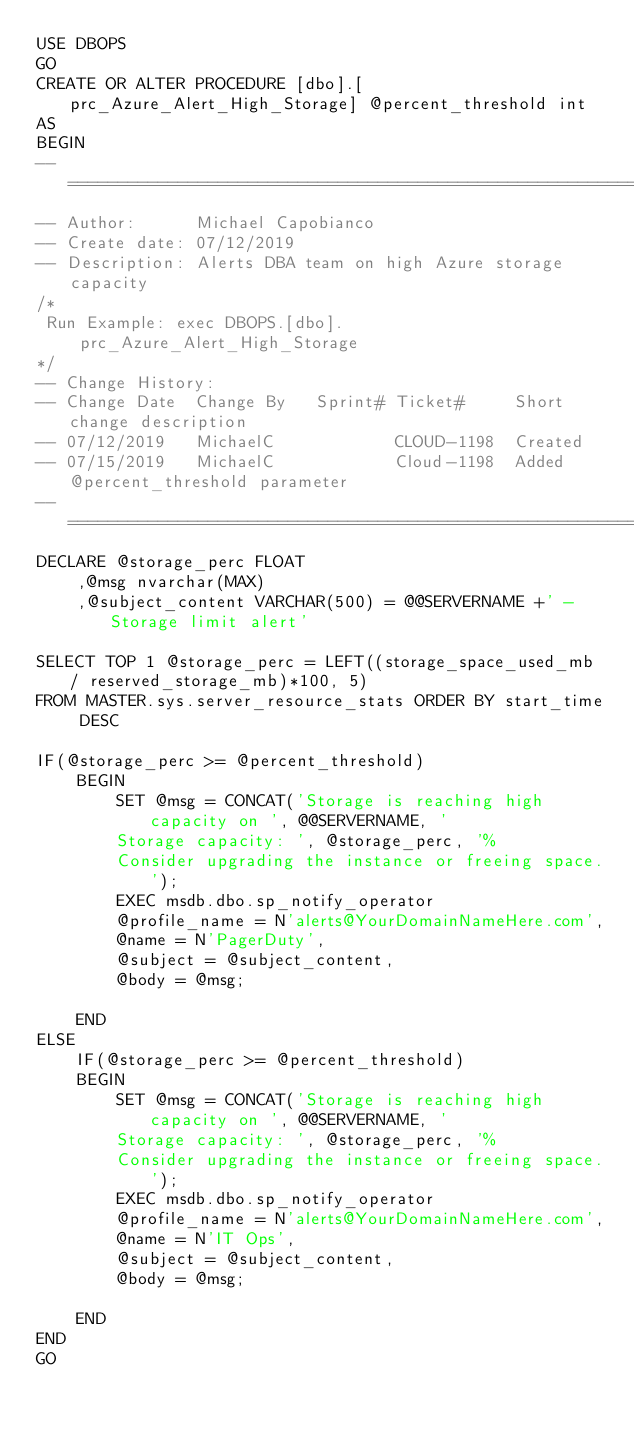<code> <loc_0><loc_0><loc_500><loc_500><_SQL_>USE DBOPS
GO
CREATE OR ALTER PROCEDURE [dbo].[prc_Azure_Alert_High_Storage] @percent_threshold int
AS
BEGIN
-- ======================================================================================
-- Author:		Michael Capobianco
-- Create date: 07/12/2019
-- Description:	Alerts DBA team on high Azure storage capacity
/*
 Run Example: exec DBOPS.[dbo].prc_Azure_Alert_High_Storage
*/
-- Change History:
-- Change Date	Change By	Sprint#	Ticket#		Short change description
-- 07/12/2019	MichaelC			CLOUD-1198 	Created
-- 07/15/2019	MichaelC			Cloud-1198	Added @percent_threshold parameter
-- ======================================================================================
DECLARE @storage_perc FLOAT
	,@msg nvarchar(MAX)
	,@subject_content VARCHAR(500) = @@SERVERNAME +' - Storage limit alert'

SELECT TOP 1 @storage_perc = LEFT((storage_space_used_mb / reserved_storage_mb)*100, 5)
FROM MASTER.sys.server_resource_stats ORDER BY start_time DESC

IF(@storage_perc >= @percent_threshold)
	BEGIN
		SET @msg = CONCAT('Storage is reaching high capacity on ', @@SERVERNAME, '
		Storage capacity: ', @storage_perc, '%
		Consider upgrading the instance or freeing space.');
		EXEC msdb.dbo.sp_notify_operator 
		@profile_name = N'alerts@YourDomainNameHere.com', 
		@name = N'PagerDuty', 
		@subject = @subject_content, 
		@body = @msg;

	END
ELSE
	IF(@storage_perc >= @percent_threshold)
	BEGIN
		SET @msg = CONCAT('Storage is reaching high capacity on ', @@SERVERNAME, '
		Storage capacity: ', @storage_perc, '%
		Consider upgrading the instance or freeing space.');
		EXEC msdb.dbo.sp_notify_operator 
		@profile_name = N'alerts@YourDomainNameHere.com', 
		@name = N'IT Ops', 
		@subject = @subject_content, 
		@body = @msg;

	END
END
GO
</code> 